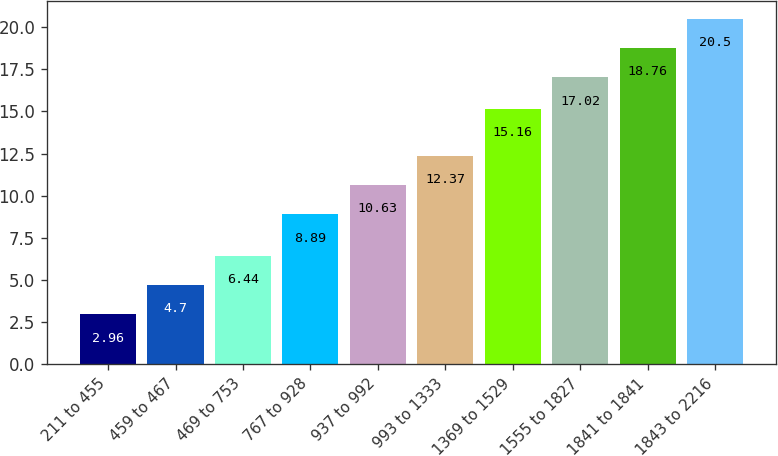<chart> <loc_0><loc_0><loc_500><loc_500><bar_chart><fcel>211 to 455<fcel>459 to 467<fcel>469 to 753<fcel>767 to 928<fcel>937 to 992<fcel>993 to 1333<fcel>1369 to 1529<fcel>1555 to 1827<fcel>1841 to 1841<fcel>1843 to 2216<nl><fcel>2.96<fcel>4.7<fcel>6.44<fcel>8.89<fcel>10.63<fcel>12.37<fcel>15.16<fcel>17.02<fcel>18.76<fcel>20.5<nl></chart> 